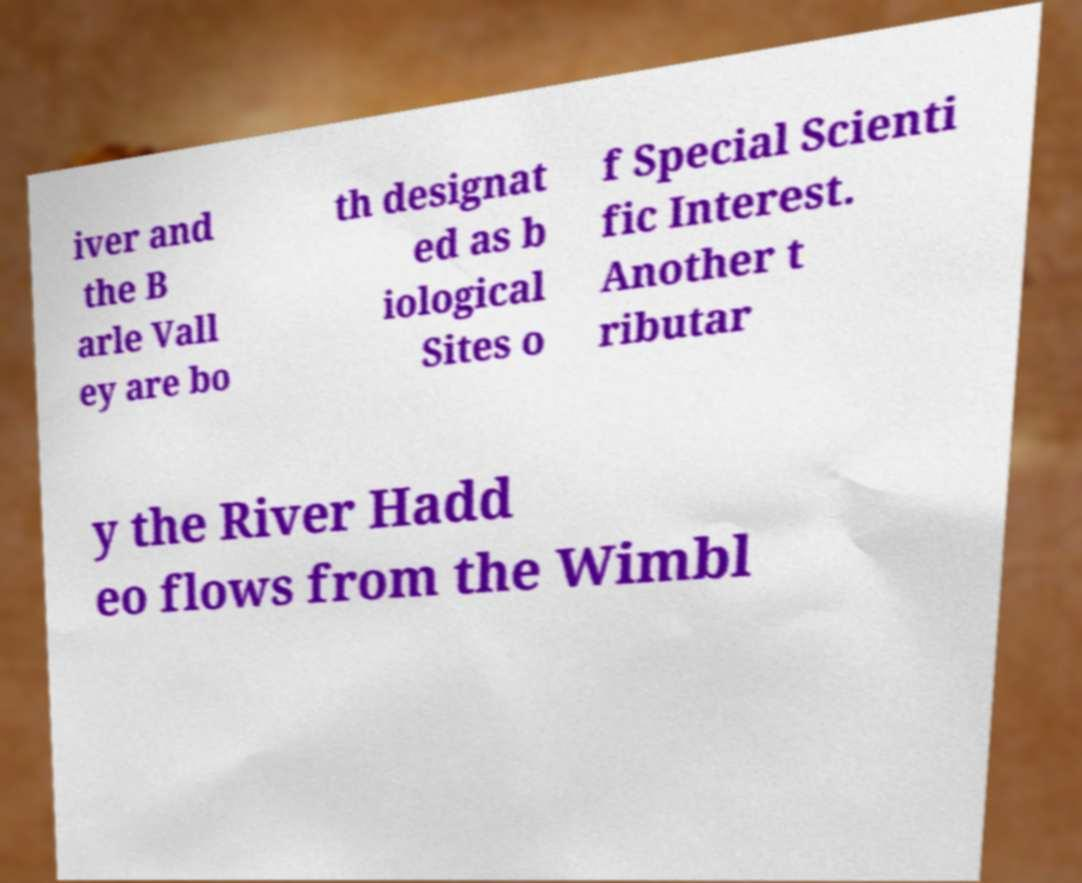I need the written content from this picture converted into text. Can you do that? iver and the B arle Vall ey are bo th designat ed as b iological Sites o f Special Scienti fic Interest. Another t ributar y the River Hadd eo flows from the Wimbl 